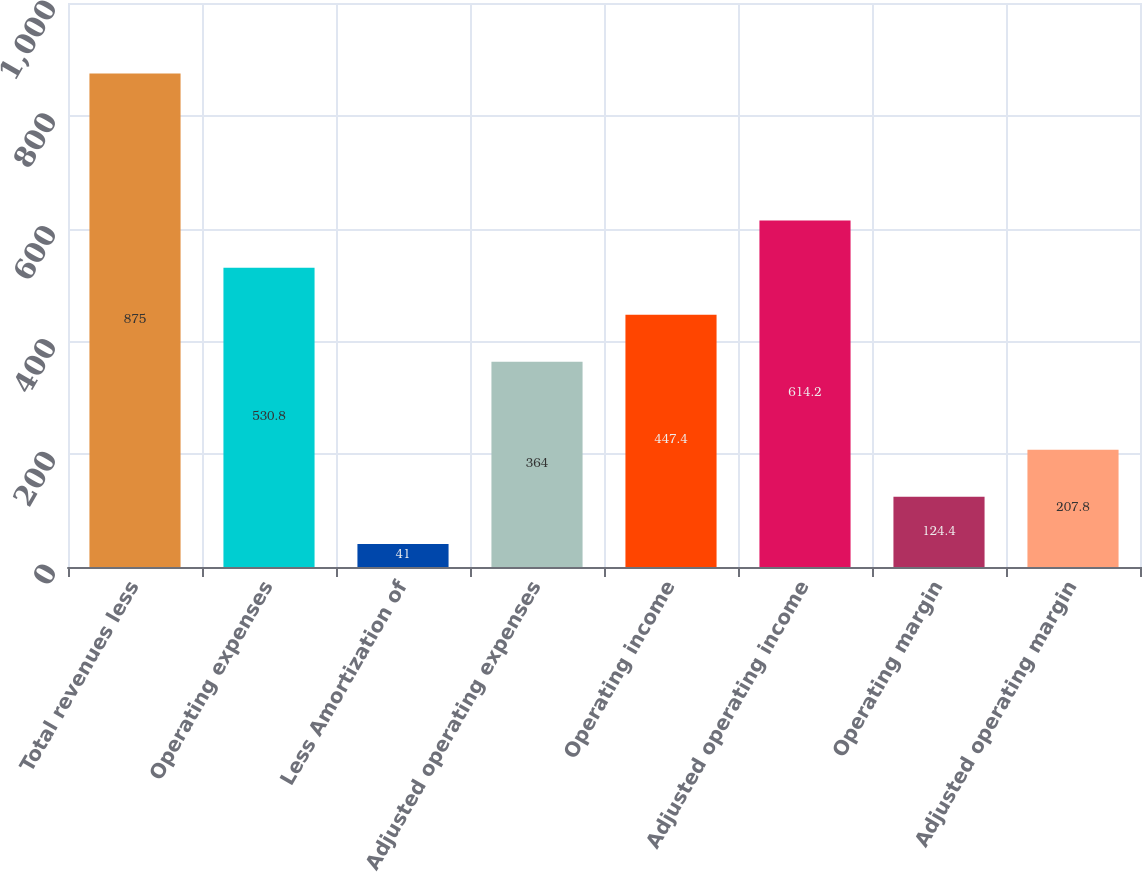Convert chart. <chart><loc_0><loc_0><loc_500><loc_500><bar_chart><fcel>Total revenues less<fcel>Operating expenses<fcel>Less Amortization of<fcel>Adjusted operating expenses<fcel>Operating income<fcel>Adjusted operating income<fcel>Operating margin<fcel>Adjusted operating margin<nl><fcel>875<fcel>530.8<fcel>41<fcel>364<fcel>447.4<fcel>614.2<fcel>124.4<fcel>207.8<nl></chart> 